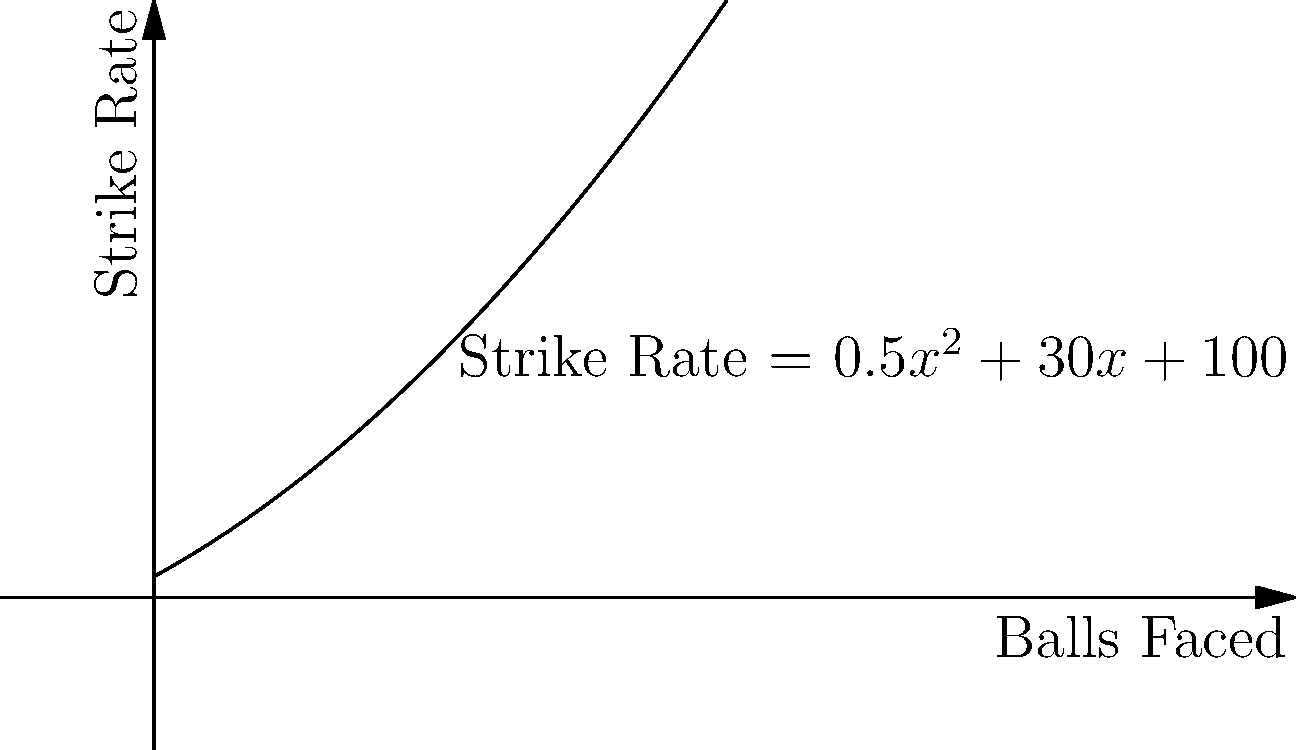Jhulan Goswami's strike rate (runs scored per 100 balls) in a T20I match is given by the function $S(x) = 0.5x^2 + 30x + 100$, where $x$ is the number of balls she has faced. At what point in her innings is her strike rate increasing at a rate of 70 runs per 100 balls per ball faced? To solve this problem, we need to follow these steps:

1) The rate of change of the strike rate is given by the derivative of $S(x)$ with respect to $x$.

2) Let's calculate $S'(x)$:
   $S'(x) = \frac{d}{dx}(0.5x^2 + 30x + 100)$
   $S'(x) = x + 30$

3) We're looking for the point where $S'(x) = 70$, as this represents the rate of increase of 70 runs per 100 balls per ball faced.

4) So, we set up the equation:
   $x + 30 = 70$

5) Solving for $x$:
   $x = 40$

6) Therefore, Jhulan's strike rate is increasing at a rate of 70 runs per 100 balls per ball faced when she has faced 40 balls.

7) To verify, we can calculate the strike rate at this point:
   $S(40) = 0.5(40)^2 + 30(40) + 100 = 800 + 1200 + 100 = 2100$

This means after 40 balls, Jhulan's strike rate would be 210, which is reasonable for a T20I innings.
Answer: After facing 40 balls 